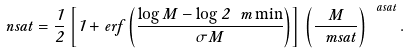<formula> <loc_0><loc_0><loc_500><loc_500>\ n s a t = \frac { 1 } { 2 } \left [ 1 + e r f \left ( \frac { \log M - \log 2 \ m \min } { \sigma M } \right ) \right ] \, \left ( \frac { M } { \ m s a t } \right ) ^ { \ a s a t } .</formula> 